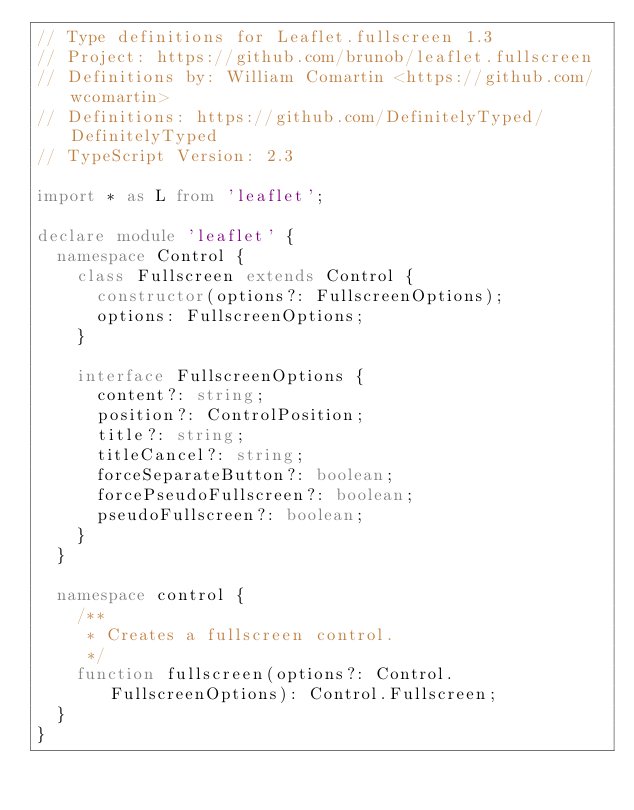Convert code to text. <code><loc_0><loc_0><loc_500><loc_500><_TypeScript_>// Type definitions for Leaflet.fullscreen 1.3
// Project: https://github.com/brunob/leaflet.fullscreen
// Definitions by: William Comartin <https://github.com/wcomartin>
// Definitions: https://github.com/DefinitelyTyped/DefinitelyTyped
// TypeScript Version: 2.3

import * as L from 'leaflet';

declare module 'leaflet' {
  namespace Control {
    class Fullscreen extends Control {
      constructor(options?: FullscreenOptions);
      options: FullscreenOptions;
    }

    interface FullscreenOptions {
      content?: string;
      position?: ControlPosition;
      title?: string;
      titleCancel?: string;
      forceSeparateButton?: boolean;
      forcePseudoFullscreen?: boolean;
      pseudoFullscreen?: boolean;
    }
  }

  namespace control {
    /**
     * Creates a fullscreen control.
     */
    function fullscreen(options?: Control.FullscreenOptions): Control.Fullscreen;
  }
}
</code> 